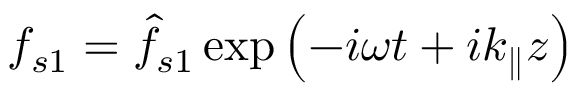<formula> <loc_0><loc_0><loc_500><loc_500>f _ { s 1 } = \hat { f } _ { s 1 } \exp \left ( - i \omega t + i k _ { \| } z \right )</formula> 